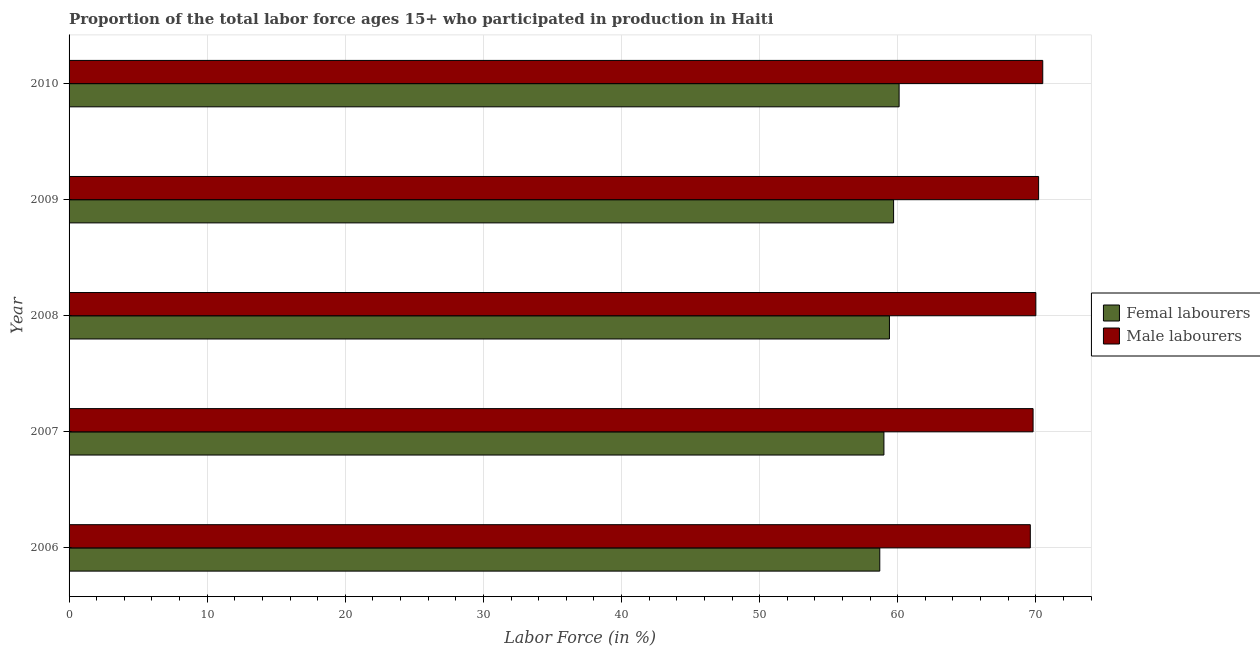How many groups of bars are there?
Offer a very short reply. 5. Are the number of bars per tick equal to the number of legend labels?
Your response must be concise. Yes. Are the number of bars on each tick of the Y-axis equal?
Make the answer very short. Yes. How many bars are there on the 2nd tick from the bottom?
Ensure brevity in your answer.  2. In how many cases, is the number of bars for a given year not equal to the number of legend labels?
Your answer should be very brief. 0. What is the percentage of female labor force in 2010?
Make the answer very short. 60.1. Across all years, what is the maximum percentage of male labour force?
Keep it short and to the point. 70.5. Across all years, what is the minimum percentage of male labour force?
Make the answer very short. 69.6. What is the total percentage of female labor force in the graph?
Offer a terse response. 296.9. What is the difference between the percentage of male labour force in 2008 and the percentage of female labor force in 2007?
Provide a short and direct response. 11. What is the average percentage of male labour force per year?
Provide a succinct answer. 70.02. In the year 2006, what is the difference between the percentage of female labor force and percentage of male labour force?
Provide a succinct answer. -10.9. In how many years, is the percentage of female labor force greater than 46 %?
Give a very brief answer. 5. What is the ratio of the percentage of female labor force in 2006 to that in 2007?
Keep it short and to the point. 0.99. What is the difference between the highest and the second highest percentage of male labour force?
Keep it short and to the point. 0.3. What is the difference between the highest and the lowest percentage of female labor force?
Provide a succinct answer. 1.4. In how many years, is the percentage of male labour force greater than the average percentage of male labour force taken over all years?
Give a very brief answer. 2. What does the 2nd bar from the top in 2010 represents?
Your answer should be very brief. Femal labourers. What does the 1st bar from the bottom in 2009 represents?
Offer a very short reply. Femal labourers. Are all the bars in the graph horizontal?
Provide a succinct answer. Yes. How many years are there in the graph?
Make the answer very short. 5. Where does the legend appear in the graph?
Your answer should be compact. Center right. How are the legend labels stacked?
Keep it short and to the point. Vertical. What is the title of the graph?
Provide a short and direct response. Proportion of the total labor force ages 15+ who participated in production in Haiti. Does "IMF concessional" appear as one of the legend labels in the graph?
Your answer should be compact. No. What is the label or title of the Y-axis?
Ensure brevity in your answer.  Year. What is the Labor Force (in %) of Femal labourers in 2006?
Offer a very short reply. 58.7. What is the Labor Force (in %) of Male labourers in 2006?
Give a very brief answer. 69.6. What is the Labor Force (in %) in Male labourers in 2007?
Provide a succinct answer. 69.8. What is the Labor Force (in %) of Femal labourers in 2008?
Your answer should be very brief. 59.4. What is the Labor Force (in %) in Male labourers in 2008?
Your answer should be very brief. 70. What is the Labor Force (in %) of Femal labourers in 2009?
Provide a short and direct response. 59.7. What is the Labor Force (in %) of Male labourers in 2009?
Your answer should be very brief. 70.2. What is the Labor Force (in %) in Femal labourers in 2010?
Offer a very short reply. 60.1. What is the Labor Force (in %) in Male labourers in 2010?
Offer a very short reply. 70.5. Across all years, what is the maximum Labor Force (in %) of Femal labourers?
Provide a succinct answer. 60.1. Across all years, what is the maximum Labor Force (in %) in Male labourers?
Give a very brief answer. 70.5. Across all years, what is the minimum Labor Force (in %) in Femal labourers?
Provide a short and direct response. 58.7. Across all years, what is the minimum Labor Force (in %) in Male labourers?
Offer a very short reply. 69.6. What is the total Labor Force (in %) of Femal labourers in the graph?
Your answer should be very brief. 296.9. What is the total Labor Force (in %) of Male labourers in the graph?
Your answer should be compact. 350.1. What is the difference between the Labor Force (in %) in Femal labourers in 2006 and that in 2008?
Offer a very short reply. -0.7. What is the difference between the Labor Force (in %) of Femal labourers in 2006 and that in 2010?
Keep it short and to the point. -1.4. What is the difference between the Labor Force (in %) of Male labourers in 2006 and that in 2010?
Keep it short and to the point. -0.9. What is the difference between the Labor Force (in %) in Male labourers in 2007 and that in 2009?
Your answer should be compact. -0.4. What is the difference between the Labor Force (in %) of Femal labourers in 2007 and that in 2010?
Offer a very short reply. -1.1. What is the difference between the Labor Force (in %) in Male labourers in 2007 and that in 2010?
Your answer should be very brief. -0.7. What is the difference between the Labor Force (in %) of Femal labourers in 2008 and that in 2010?
Offer a very short reply. -0.7. What is the difference between the Labor Force (in %) of Femal labourers in 2009 and that in 2010?
Your answer should be compact. -0.4. What is the difference between the Labor Force (in %) of Femal labourers in 2006 and the Labor Force (in %) of Male labourers in 2007?
Give a very brief answer. -11.1. What is the difference between the Labor Force (in %) in Femal labourers in 2006 and the Labor Force (in %) in Male labourers in 2009?
Give a very brief answer. -11.5. What is the difference between the Labor Force (in %) in Femal labourers in 2007 and the Labor Force (in %) in Male labourers in 2008?
Offer a very short reply. -11. What is the difference between the Labor Force (in %) in Femal labourers in 2007 and the Labor Force (in %) in Male labourers in 2009?
Offer a very short reply. -11.2. What is the difference between the Labor Force (in %) in Femal labourers in 2007 and the Labor Force (in %) in Male labourers in 2010?
Provide a succinct answer. -11.5. What is the difference between the Labor Force (in %) in Femal labourers in 2008 and the Labor Force (in %) in Male labourers in 2009?
Keep it short and to the point. -10.8. What is the difference between the Labor Force (in %) of Femal labourers in 2009 and the Labor Force (in %) of Male labourers in 2010?
Provide a short and direct response. -10.8. What is the average Labor Force (in %) in Femal labourers per year?
Provide a succinct answer. 59.38. What is the average Labor Force (in %) of Male labourers per year?
Offer a very short reply. 70.02. In the year 2006, what is the difference between the Labor Force (in %) of Femal labourers and Labor Force (in %) of Male labourers?
Ensure brevity in your answer.  -10.9. What is the ratio of the Labor Force (in %) in Male labourers in 2006 to that in 2007?
Offer a terse response. 1. What is the ratio of the Labor Force (in %) in Femal labourers in 2006 to that in 2008?
Offer a terse response. 0.99. What is the ratio of the Labor Force (in %) in Femal labourers in 2006 to that in 2009?
Your response must be concise. 0.98. What is the ratio of the Labor Force (in %) of Male labourers in 2006 to that in 2009?
Give a very brief answer. 0.99. What is the ratio of the Labor Force (in %) of Femal labourers in 2006 to that in 2010?
Your answer should be compact. 0.98. What is the ratio of the Labor Force (in %) of Male labourers in 2006 to that in 2010?
Make the answer very short. 0.99. What is the ratio of the Labor Force (in %) of Femal labourers in 2007 to that in 2009?
Make the answer very short. 0.99. What is the ratio of the Labor Force (in %) in Femal labourers in 2007 to that in 2010?
Provide a succinct answer. 0.98. What is the ratio of the Labor Force (in %) in Femal labourers in 2008 to that in 2009?
Your response must be concise. 0.99. What is the ratio of the Labor Force (in %) of Male labourers in 2008 to that in 2009?
Offer a very short reply. 1. What is the ratio of the Labor Force (in %) in Femal labourers in 2008 to that in 2010?
Your response must be concise. 0.99. What is the ratio of the Labor Force (in %) of Male labourers in 2008 to that in 2010?
Make the answer very short. 0.99. What is the difference between the highest and the second highest Labor Force (in %) of Male labourers?
Offer a very short reply. 0.3. What is the difference between the highest and the lowest Labor Force (in %) in Femal labourers?
Provide a short and direct response. 1.4. What is the difference between the highest and the lowest Labor Force (in %) of Male labourers?
Make the answer very short. 0.9. 